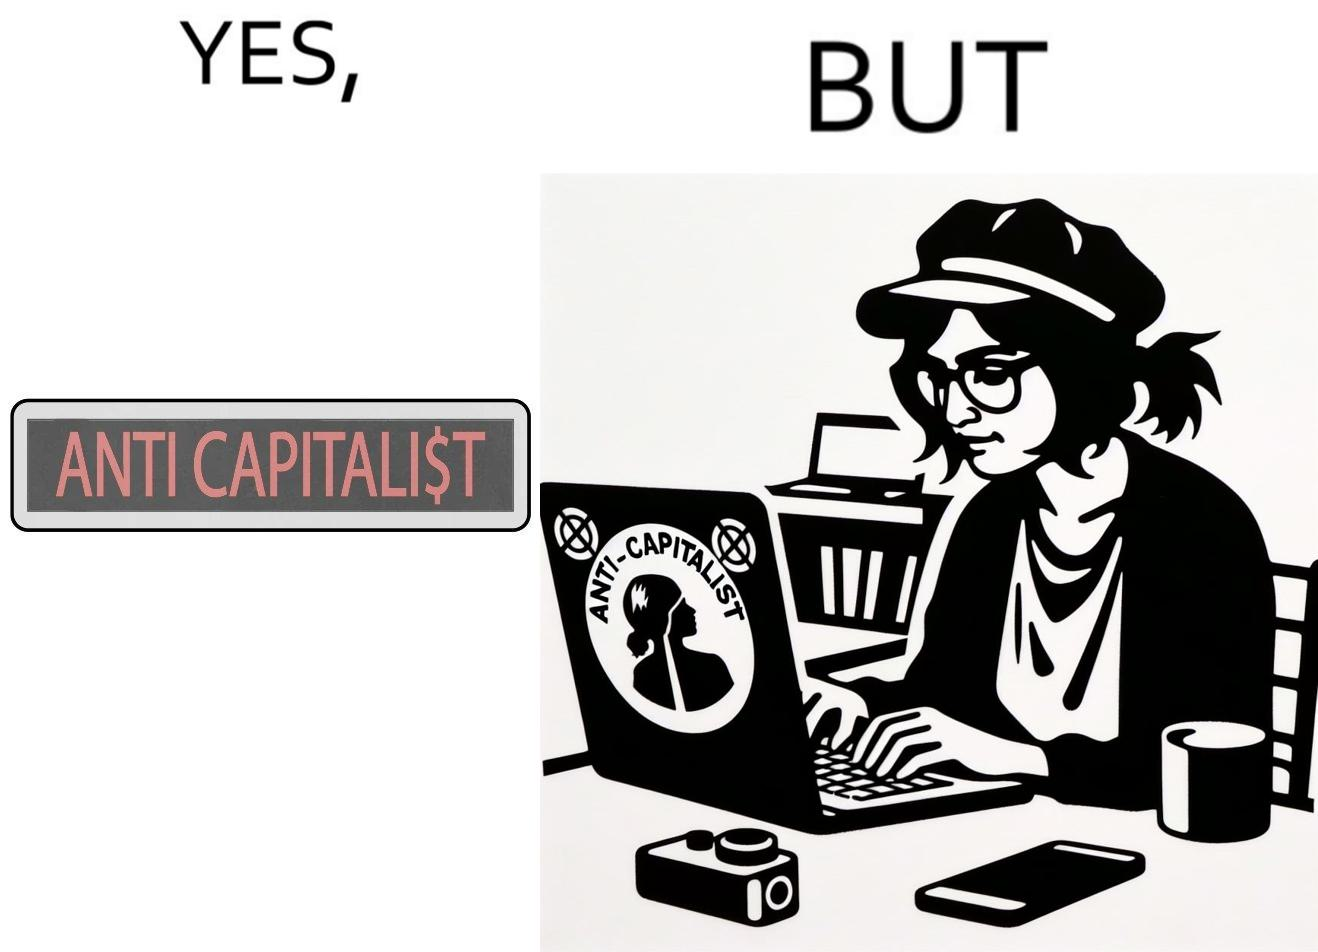Is this image satirical or non-satirical? Yes, this image is satirical. 